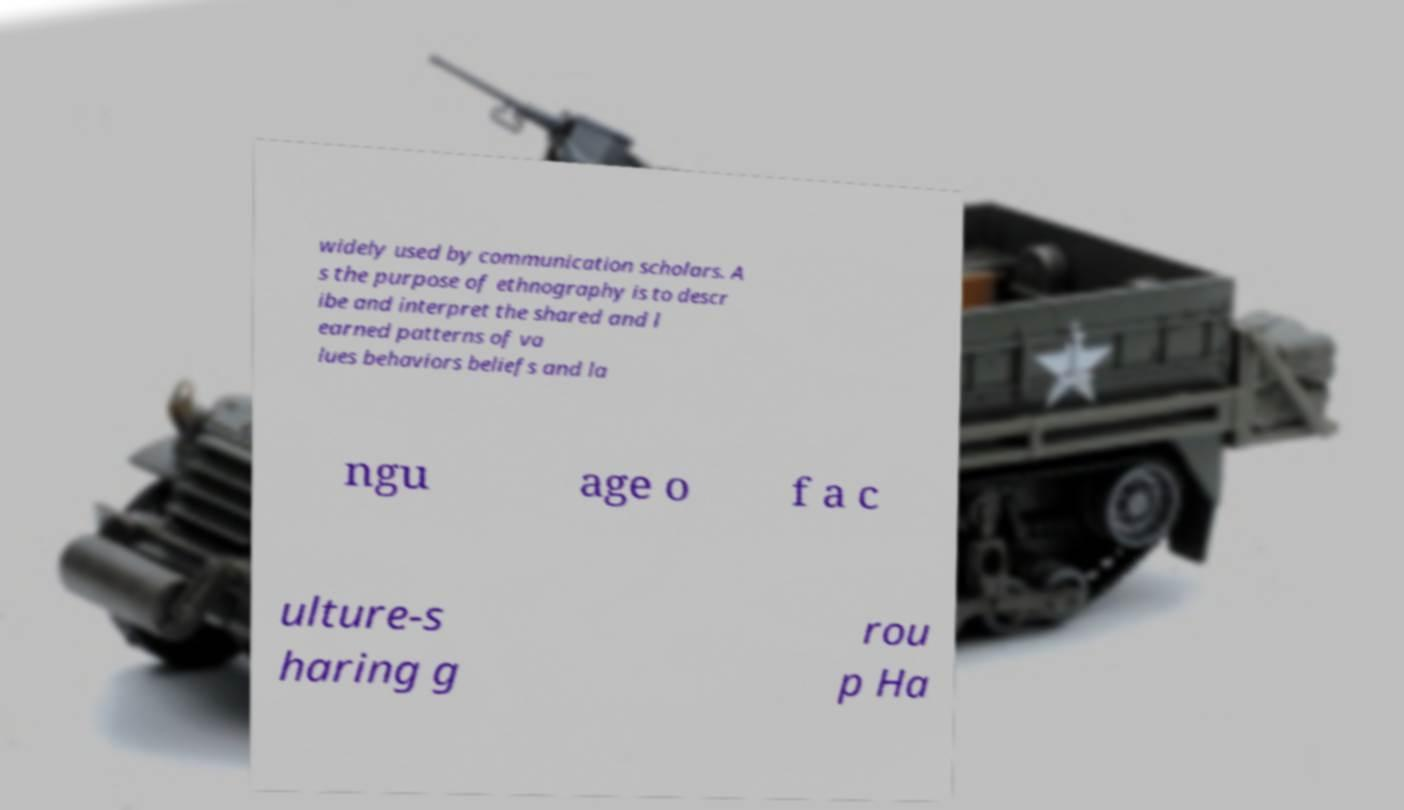For documentation purposes, I need the text within this image transcribed. Could you provide that? widely used by communication scholars. A s the purpose of ethnography is to descr ibe and interpret the shared and l earned patterns of va lues behaviors beliefs and la ngu age o f a c ulture-s haring g rou p Ha 